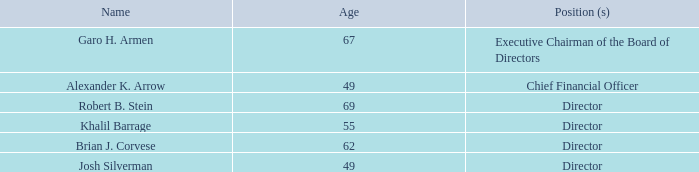Item 10. Directors, Executive Officers and Corporate Governance.
Executive Officers and Directors
The following sets forth certain information with respect to our executive officers and directors..
Garo H. Armen, PhD, Executive Chairman, is one of our founders and joined us in September 2004. Garo H. Armen is Chairman and Chief Executive Officer of Agenus
Inc., a biotechnology company he co-founded in 1994. From mid-2002 through 2004, he also served as Chairman of the Board of the biopharmaceutical company Elan
Corporation, plc, which he successfully restructured. Prior to Agenus Inc., Dr. Armen established Armen Partners, a money management firm specializing in biotechnology and
pharmaceutical companies and was the architect of the widely publicized creation of the Immunex Lederle oncology business in 1993. Earlier, he was a senior vice president of
research at Dean Witter Reynolds, having begun his career on Wall Street as an analyst and investment banker at EF Hutton. In 2002, Dr. Armen founded the Children of
Armenia Fund, a nonprofit organization dedicated to significantly rebuilding and revitalizing impoverished rural Armenian towns to provide immediate and sustainable benefits
to children and youth. He received the Ellis Island Medal of Honor in 2004 for his humanitarian efforts, and received the Sabin Humanitarian Award from the Sabin Vaccine
Institute in 2006 for his achievements in biotechnology and progressing medical research. Dr. Armen was also the Ernst & Young 2002 New York City Biotechnology
Entrepreneur of the Year, and received a Wings of Hope Award in 2005 from The Melanoma Research Foundation for his ongoing commitment to the melanoma community. Dr.
Armen received a PhD in physical chemistry from the Graduate Center, City University of New York, after which he worked as a research fellow at Brookhaven National
Laboratories in Long Island, NY. Dr. Armen brings to our Board a deep historical and practical knowledge of the business of the Company and its technologies, as well as
years of expertise in the financial and biopharmaceutical arenas.
Who is the Executive chairman of the Board of Directors? Garo h. armen. Who is the Chief Financial Officer of the company? Alexander k. arrow. When did the Executive Chairman join the company? September 2004. How many directors are there in the company? Robert B. Stein ## Khalil Barrage ## Brian J. Corvese ## Josh Silverman
Answer: 4. What is the average age of the directors in the company? (69 + 55 + 62 + 49)/4 
Answer: 58.75. Who is the oldest director within the company's Board of Directors? Obtained from the table
Answer: robert b. stein. 